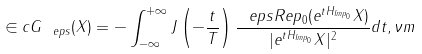<formula> <loc_0><loc_0><loc_500><loc_500>\in c G _ { \ e p s } ( X ) = - \int _ { - \infty } ^ { + \infty } J \left ( - \frac { t } { T } \right ) \frac { \ e p s R e p _ { 0 } ( e ^ { t H _ { I m p _ { 0 } } } X ) } { | e ^ { t H _ { I m p _ { 0 } } } X | ^ { 2 } } d t , \nu m</formula> 